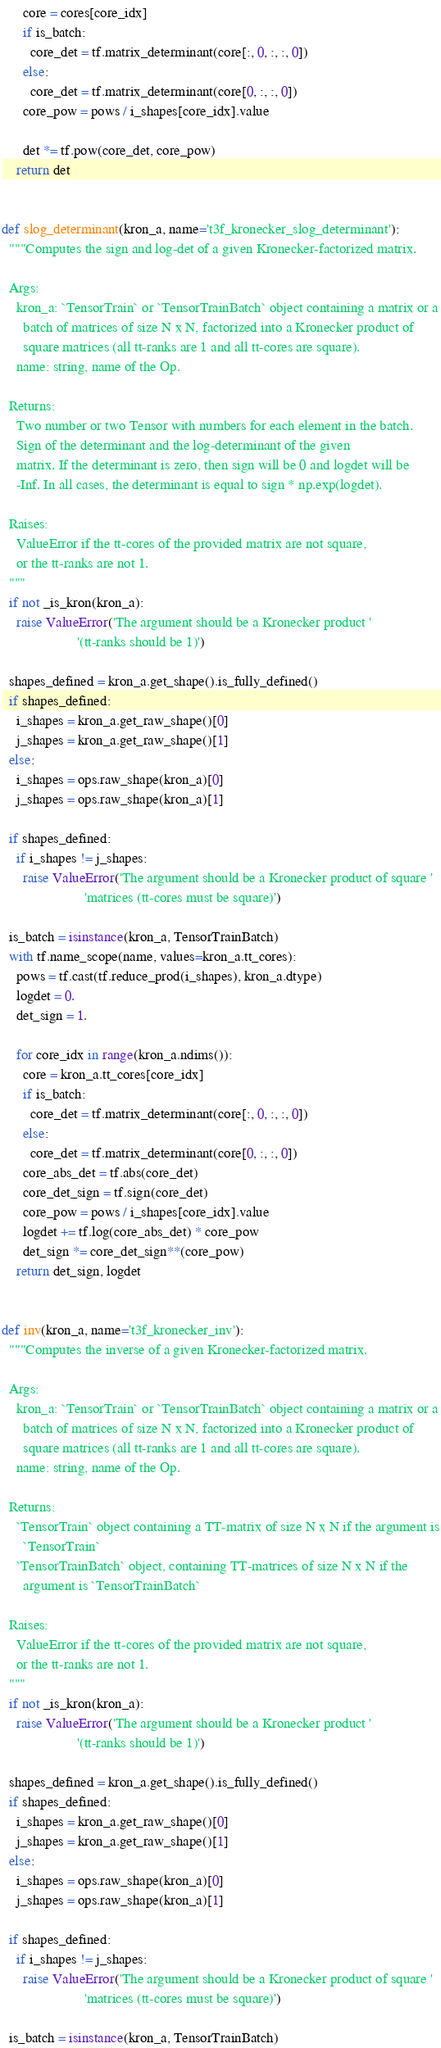Convert code to text. <code><loc_0><loc_0><loc_500><loc_500><_Python_>      core = cores[core_idx]
      if is_batch:
        core_det = tf.matrix_determinant(core[:, 0, :, :, 0])
      else:
        core_det = tf.matrix_determinant(core[0, :, :, 0])
      core_pow = pows / i_shapes[core_idx].value

      det *= tf.pow(core_det, core_pow)
    return det


def slog_determinant(kron_a, name='t3f_kronecker_slog_determinant'):
  """Computes the sign and log-det of a given Kronecker-factorized matrix.

  Args:
    kron_a: `TensorTrain` or `TensorTrainBatch` object containing a matrix or a
      batch of matrices of size N x N, factorized into a Kronecker product of 
      square matrices (all tt-ranks are 1 and all tt-cores are square). 
    name: string, name of the Op.
  
  Returns:
    Two number or two Tensor with numbers for each element in the batch.
    Sign of the determinant and the log-determinant of the given 
    matrix. If the determinant is zero, then sign will be 0 and logdet will be
    -Inf. In all cases, the determinant is equal to sign * np.exp(logdet).

  Raises:
    ValueError if the tt-cores of the provided matrix are not square,
    or the tt-ranks are not 1.
  """
  if not _is_kron(kron_a):
    raise ValueError('The argument should be a Kronecker product ' 
                     '(tt-ranks should be 1)')
 
  shapes_defined = kron_a.get_shape().is_fully_defined()
  if shapes_defined:
    i_shapes = kron_a.get_raw_shape()[0]
    j_shapes = kron_a.get_raw_shape()[1]
  else:
    i_shapes = ops.raw_shape(kron_a)[0]
    j_shapes = ops.raw_shape(kron_a)[1]

  if shapes_defined:
    if i_shapes != j_shapes:
      raise ValueError('The argument should be a Kronecker product of square '
                       'matrices (tt-cores must be square)')

  is_batch = isinstance(kron_a, TensorTrainBatch)
  with tf.name_scope(name, values=kron_a.tt_cores):
    pows = tf.cast(tf.reduce_prod(i_shapes), kron_a.dtype)
    logdet = 0.
    det_sign = 1.

    for core_idx in range(kron_a.ndims()):
      core = kron_a.tt_cores[core_idx]
      if is_batch:
        core_det = tf.matrix_determinant(core[:, 0, :, :, 0])
      else:
        core_det = tf.matrix_determinant(core[0, :, :, 0])
      core_abs_det = tf.abs(core_det)
      core_det_sign = tf.sign(core_det)
      core_pow = pows / i_shapes[core_idx].value
      logdet += tf.log(core_abs_det) * core_pow
      det_sign *= core_det_sign**(core_pow)
    return det_sign, logdet


def inv(kron_a, name='t3f_kronecker_inv'):
  """Computes the inverse of a given Kronecker-factorized matrix.

  Args:
    kron_a: `TensorTrain` or `TensorTrainBatch` object containing a matrix or a
      batch of matrices of size N x N, factorized into a Kronecker product of 
      square matrices (all tt-ranks are 1 and all tt-cores are square). 
    name: string, name of the Op.

  Returns:
    `TensorTrain` object containing a TT-matrix of size N x N if the argument is
      `TensorTrain`
    `TensorTrainBatch` object, containing TT-matrices of size N x N if the 
      argument is `TensorTrainBatch`  
  
  Raises:
    ValueError if the tt-cores of the provided matrix are not square,
    or the tt-ranks are not 1.
  """
  if not _is_kron(kron_a):
    raise ValueError('The argument should be a Kronecker product ' 
                     '(tt-ranks should be 1)')
    
  shapes_defined = kron_a.get_shape().is_fully_defined()
  if shapes_defined:
    i_shapes = kron_a.get_raw_shape()[0]
    j_shapes = kron_a.get_raw_shape()[1]
  else:
    i_shapes = ops.raw_shape(kron_a)[0]
    j_shapes = ops.raw_shape(kron_a)[1]

  if shapes_defined:
    if i_shapes != j_shapes:
      raise ValueError('The argument should be a Kronecker product of square '
                       'matrices (tt-cores must be square)')

  is_batch = isinstance(kron_a, TensorTrainBatch)</code> 